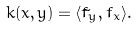<formula> <loc_0><loc_0><loc_500><loc_500>k ( x , y ) = \langle \tilde { f } _ { y } , f _ { x } \rangle .</formula> 